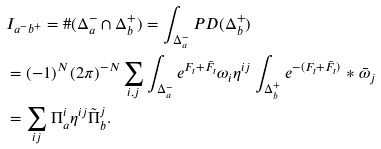Convert formula to latex. <formula><loc_0><loc_0><loc_500><loc_500>& I _ { a ^ { - } b ^ { + } } = \# ( \Delta ^ { - } _ { a } \cap \Delta ^ { + } _ { b } ) = \int _ { \Delta _ { a } ^ { - } } P D ( \Delta _ { b } ^ { + } ) \\ & = ( - 1 ) ^ { N } ( 2 \pi ) ^ { - N } \sum _ { i , j } \int _ { \Delta _ { a } ^ { - } } e ^ { F _ { t } + \bar { F } _ { t } } \omega _ { i } \eta ^ { i j } \int _ { \Delta ^ { + } _ { b } } e ^ { - ( F _ { t } + \bar { F } _ { t } ) } * \bar { \omega } _ { j } \\ & = \sum _ { i j } \Pi ^ { i } _ { a } \eta ^ { i j } \tilde { \Pi } ^ { j } _ { b } .</formula> 